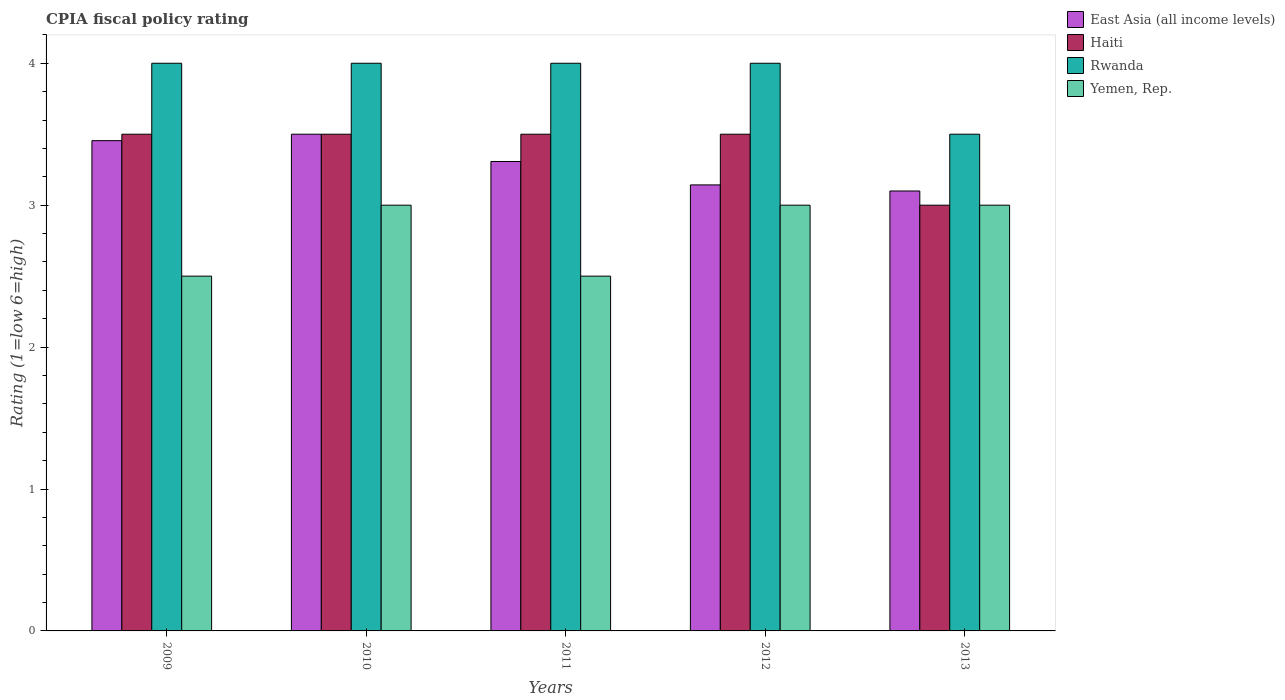How many different coloured bars are there?
Your answer should be compact. 4. Are the number of bars per tick equal to the number of legend labels?
Make the answer very short. Yes. How many bars are there on the 3rd tick from the left?
Make the answer very short. 4. How many bars are there on the 3rd tick from the right?
Your answer should be compact. 4. What is the label of the 1st group of bars from the left?
Make the answer very short. 2009. What is the CPIA rating in Rwanda in 2010?
Give a very brief answer. 4. Across all years, what is the maximum CPIA rating in East Asia (all income levels)?
Provide a succinct answer. 3.5. What is the total CPIA rating in East Asia (all income levels) in the graph?
Your response must be concise. 16.51. What is the difference between the CPIA rating in East Asia (all income levels) in 2009 and that in 2013?
Provide a succinct answer. 0.35. What is the difference between the CPIA rating in East Asia (all income levels) in 2012 and the CPIA rating in Rwanda in 2013?
Provide a succinct answer. -0.36. What is the average CPIA rating in Rwanda per year?
Your response must be concise. 3.9. In the year 2010, what is the difference between the CPIA rating in Yemen, Rep. and CPIA rating in East Asia (all income levels)?
Provide a short and direct response. -0.5. Is the CPIA rating in Rwanda in 2010 less than that in 2012?
Provide a succinct answer. No. What is the difference between the highest and the second highest CPIA rating in Yemen, Rep.?
Provide a succinct answer. 0. What is the difference between the highest and the lowest CPIA rating in East Asia (all income levels)?
Your response must be concise. 0.4. In how many years, is the CPIA rating in Yemen, Rep. greater than the average CPIA rating in Yemen, Rep. taken over all years?
Ensure brevity in your answer.  3. What does the 1st bar from the left in 2011 represents?
Keep it short and to the point. East Asia (all income levels). What does the 4th bar from the right in 2009 represents?
Give a very brief answer. East Asia (all income levels). Are all the bars in the graph horizontal?
Provide a short and direct response. No. Does the graph contain any zero values?
Provide a succinct answer. No. Does the graph contain grids?
Provide a succinct answer. No. Where does the legend appear in the graph?
Your answer should be very brief. Top right. How are the legend labels stacked?
Offer a very short reply. Vertical. What is the title of the graph?
Provide a succinct answer. CPIA fiscal policy rating. What is the label or title of the Y-axis?
Provide a short and direct response. Rating (1=low 6=high). What is the Rating (1=low 6=high) in East Asia (all income levels) in 2009?
Your answer should be very brief. 3.45. What is the Rating (1=low 6=high) of Yemen, Rep. in 2009?
Offer a terse response. 2.5. What is the Rating (1=low 6=high) of Rwanda in 2010?
Offer a terse response. 4. What is the Rating (1=low 6=high) in Yemen, Rep. in 2010?
Give a very brief answer. 3. What is the Rating (1=low 6=high) of East Asia (all income levels) in 2011?
Your answer should be very brief. 3.31. What is the Rating (1=low 6=high) in Haiti in 2011?
Ensure brevity in your answer.  3.5. What is the Rating (1=low 6=high) of Rwanda in 2011?
Offer a very short reply. 4. What is the Rating (1=low 6=high) in East Asia (all income levels) in 2012?
Give a very brief answer. 3.14. What is the Rating (1=low 6=high) of Haiti in 2013?
Give a very brief answer. 3. What is the Rating (1=low 6=high) of Rwanda in 2013?
Give a very brief answer. 3.5. What is the Rating (1=low 6=high) in Yemen, Rep. in 2013?
Make the answer very short. 3. Across all years, what is the maximum Rating (1=low 6=high) in East Asia (all income levels)?
Make the answer very short. 3.5. Across all years, what is the maximum Rating (1=low 6=high) of Rwanda?
Offer a very short reply. 4. Across all years, what is the maximum Rating (1=low 6=high) in Yemen, Rep.?
Your response must be concise. 3. Across all years, what is the minimum Rating (1=low 6=high) of East Asia (all income levels)?
Offer a very short reply. 3.1. What is the total Rating (1=low 6=high) in East Asia (all income levels) in the graph?
Ensure brevity in your answer.  16.51. What is the total Rating (1=low 6=high) in Haiti in the graph?
Ensure brevity in your answer.  17. What is the total Rating (1=low 6=high) in Yemen, Rep. in the graph?
Make the answer very short. 14. What is the difference between the Rating (1=low 6=high) in East Asia (all income levels) in 2009 and that in 2010?
Make the answer very short. -0.05. What is the difference between the Rating (1=low 6=high) of East Asia (all income levels) in 2009 and that in 2011?
Your answer should be very brief. 0.15. What is the difference between the Rating (1=low 6=high) of Rwanda in 2009 and that in 2011?
Your answer should be very brief. 0. What is the difference between the Rating (1=low 6=high) of East Asia (all income levels) in 2009 and that in 2012?
Your answer should be very brief. 0.31. What is the difference between the Rating (1=low 6=high) of Yemen, Rep. in 2009 and that in 2012?
Your answer should be very brief. -0.5. What is the difference between the Rating (1=low 6=high) of East Asia (all income levels) in 2009 and that in 2013?
Make the answer very short. 0.35. What is the difference between the Rating (1=low 6=high) of Rwanda in 2009 and that in 2013?
Your answer should be compact. 0.5. What is the difference between the Rating (1=low 6=high) of East Asia (all income levels) in 2010 and that in 2011?
Ensure brevity in your answer.  0.19. What is the difference between the Rating (1=low 6=high) of Haiti in 2010 and that in 2011?
Your answer should be compact. 0. What is the difference between the Rating (1=low 6=high) of Rwanda in 2010 and that in 2011?
Provide a short and direct response. 0. What is the difference between the Rating (1=low 6=high) of Yemen, Rep. in 2010 and that in 2011?
Your answer should be compact. 0.5. What is the difference between the Rating (1=low 6=high) of East Asia (all income levels) in 2010 and that in 2012?
Provide a succinct answer. 0.36. What is the difference between the Rating (1=low 6=high) in Haiti in 2010 and that in 2012?
Offer a very short reply. 0. What is the difference between the Rating (1=low 6=high) in Yemen, Rep. in 2010 and that in 2012?
Make the answer very short. 0. What is the difference between the Rating (1=low 6=high) of East Asia (all income levels) in 2010 and that in 2013?
Provide a short and direct response. 0.4. What is the difference between the Rating (1=low 6=high) of Haiti in 2010 and that in 2013?
Offer a terse response. 0.5. What is the difference between the Rating (1=low 6=high) of Rwanda in 2010 and that in 2013?
Your response must be concise. 0.5. What is the difference between the Rating (1=low 6=high) of East Asia (all income levels) in 2011 and that in 2012?
Offer a very short reply. 0.16. What is the difference between the Rating (1=low 6=high) of Haiti in 2011 and that in 2012?
Offer a very short reply. 0. What is the difference between the Rating (1=low 6=high) of East Asia (all income levels) in 2011 and that in 2013?
Offer a very short reply. 0.21. What is the difference between the Rating (1=low 6=high) of East Asia (all income levels) in 2012 and that in 2013?
Your answer should be very brief. 0.04. What is the difference between the Rating (1=low 6=high) in Yemen, Rep. in 2012 and that in 2013?
Make the answer very short. 0. What is the difference between the Rating (1=low 6=high) in East Asia (all income levels) in 2009 and the Rating (1=low 6=high) in Haiti in 2010?
Your answer should be compact. -0.05. What is the difference between the Rating (1=low 6=high) of East Asia (all income levels) in 2009 and the Rating (1=low 6=high) of Rwanda in 2010?
Ensure brevity in your answer.  -0.55. What is the difference between the Rating (1=low 6=high) in East Asia (all income levels) in 2009 and the Rating (1=low 6=high) in Yemen, Rep. in 2010?
Offer a terse response. 0.45. What is the difference between the Rating (1=low 6=high) in East Asia (all income levels) in 2009 and the Rating (1=low 6=high) in Haiti in 2011?
Your answer should be compact. -0.05. What is the difference between the Rating (1=low 6=high) in East Asia (all income levels) in 2009 and the Rating (1=low 6=high) in Rwanda in 2011?
Ensure brevity in your answer.  -0.55. What is the difference between the Rating (1=low 6=high) in East Asia (all income levels) in 2009 and the Rating (1=low 6=high) in Yemen, Rep. in 2011?
Your answer should be very brief. 0.95. What is the difference between the Rating (1=low 6=high) of Haiti in 2009 and the Rating (1=low 6=high) of Rwanda in 2011?
Make the answer very short. -0.5. What is the difference between the Rating (1=low 6=high) of Haiti in 2009 and the Rating (1=low 6=high) of Yemen, Rep. in 2011?
Keep it short and to the point. 1. What is the difference between the Rating (1=low 6=high) of East Asia (all income levels) in 2009 and the Rating (1=low 6=high) of Haiti in 2012?
Offer a terse response. -0.05. What is the difference between the Rating (1=low 6=high) of East Asia (all income levels) in 2009 and the Rating (1=low 6=high) of Rwanda in 2012?
Offer a terse response. -0.55. What is the difference between the Rating (1=low 6=high) in East Asia (all income levels) in 2009 and the Rating (1=low 6=high) in Yemen, Rep. in 2012?
Offer a very short reply. 0.45. What is the difference between the Rating (1=low 6=high) of Haiti in 2009 and the Rating (1=low 6=high) of Rwanda in 2012?
Make the answer very short. -0.5. What is the difference between the Rating (1=low 6=high) in Haiti in 2009 and the Rating (1=low 6=high) in Yemen, Rep. in 2012?
Keep it short and to the point. 0.5. What is the difference between the Rating (1=low 6=high) of Rwanda in 2009 and the Rating (1=low 6=high) of Yemen, Rep. in 2012?
Provide a succinct answer. 1. What is the difference between the Rating (1=low 6=high) in East Asia (all income levels) in 2009 and the Rating (1=low 6=high) in Haiti in 2013?
Keep it short and to the point. 0.45. What is the difference between the Rating (1=low 6=high) in East Asia (all income levels) in 2009 and the Rating (1=low 6=high) in Rwanda in 2013?
Your response must be concise. -0.05. What is the difference between the Rating (1=low 6=high) of East Asia (all income levels) in 2009 and the Rating (1=low 6=high) of Yemen, Rep. in 2013?
Make the answer very short. 0.45. What is the difference between the Rating (1=low 6=high) of Haiti in 2009 and the Rating (1=low 6=high) of Rwanda in 2013?
Give a very brief answer. 0. What is the difference between the Rating (1=low 6=high) in Haiti in 2010 and the Rating (1=low 6=high) in Rwanda in 2011?
Your answer should be very brief. -0.5. What is the difference between the Rating (1=low 6=high) in East Asia (all income levels) in 2010 and the Rating (1=low 6=high) in Yemen, Rep. in 2012?
Offer a terse response. 0.5. What is the difference between the Rating (1=low 6=high) in East Asia (all income levels) in 2010 and the Rating (1=low 6=high) in Haiti in 2013?
Ensure brevity in your answer.  0.5. What is the difference between the Rating (1=low 6=high) of East Asia (all income levels) in 2010 and the Rating (1=low 6=high) of Yemen, Rep. in 2013?
Give a very brief answer. 0.5. What is the difference between the Rating (1=low 6=high) of East Asia (all income levels) in 2011 and the Rating (1=low 6=high) of Haiti in 2012?
Your response must be concise. -0.19. What is the difference between the Rating (1=low 6=high) of East Asia (all income levels) in 2011 and the Rating (1=low 6=high) of Rwanda in 2012?
Your answer should be compact. -0.69. What is the difference between the Rating (1=low 6=high) in East Asia (all income levels) in 2011 and the Rating (1=low 6=high) in Yemen, Rep. in 2012?
Keep it short and to the point. 0.31. What is the difference between the Rating (1=low 6=high) of East Asia (all income levels) in 2011 and the Rating (1=low 6=high) of Haiti in 2013?
Make the answer very short. 0.31. What is the difference between the Rating (1=low 6=high) of East Asia (all income levels) in 2011 and the Rating (1=low 6=high) of Rwanda in 2013?
Your response must be concise. -0.19. What is the difference between the Rating (1=low 6=high) in East Asia (all income levels) in 2011 and the Rating (1=low 6=high) in Yemen, Rep. in 2013?
Your answer should be compact. 0.31. What is the difference between the Rating (1=low 6=high) in Haiti in 2011 and the Rating (1=low 6=high) in Yemen, Rep. in 2013?
Provide a short and direct response. 0.5. What is the difference between the Rating (1=low 6=high) of Rwanda in 2011 and the Rating (1=low 6=high) of Yemen, Rep. in 2013?
Offer a very short reply. 1. What is the difference between the Rating (1=low 6=high) in East Asia (all income levels) in 2012 and the Rating (1=low 6=high) in Haiti in 2013?
Keep it short and to the point. 0.14. What is the difference between the Rating (1=low 6=high) in East Asia (all income levels) in 2012 and the Rating (1=low 6=high) in Rwanda in 2013?
Your answer should be very brief. -0.36. What is the difference between the Rating (1=low 6=high) of East Asia (all income levels) in 2012 and the Rating (1=low 6=high) of Yemen, Rep. in 2013?
Give a very brief answer. 0.14. What is the difference between the Rating (1=low 6=high) in Haiti in 2012 and the Rating (1=low 6=high) in Yemen, Rep. in 2013?
Give a very brief answer. 0.5. What is the average Rating (1=low 6=high) of East Asia (all income levels) per year?
Your answer should be compact. 3.3. What is the average Rating (1=low 6=high) in Rwanda per year?
Ensure brevity in your answer.  3.9. What is the average Rating (1=low 6=high) in Yemen, Rep. per year?
Provide a succinct answer. 2.8. In the year 2009, what is the difference between the Rating (1=low 6=high) in East Asia (all income levels) and Rating (1=low 6=high) in Haiti?
Give a very brief answer. -0.05. In the year 2009, what is the difference between the Rating (1=low 6=high) in East Asia (all income levels) and Rating (1=low 6=high) in Rwanda?
Provide a short and direct response. -0.55. In the year 2009, what is the difference between the Rating (1=low 6=high) in East Asia (all income levels) and Rating (1=low 6=high) in Yemen, Rep.?
Your answer should be very brief. 0.95. In the year 2009, what is the difference between the Rating (1=low 6=high) in Haiti and Rating (1=low 6=high) in Rwanda?
Provide a succinct answer. -0.5. In the year 2009, what is the difference between the Rating (1=low 6=high) of Rwanda and Rating (1=low 6=high) of Yemen, Rep.?
Keep it short and to the point. 1.5. In the year 2010, what is the difference between the Rating (1=low 6=high) in East Asia (all income levels) and Rating (1=low 6=high) in Haiti?
Offer a very short reply. 0. In the year 2010, what is the difference between the Rating (1=low 6=high) in East Asia (all income levels) and Rating (1=low 6=high) in Rwanda?
Ensure brevity in your answer.  -0.5. In the year 2010, what is the difference between the Rating (1=low 6=high) of Haiti and Rating (1=low 6=high) of Rwanda?
Keep it short and to the point. -0.5. In the year 2010, what is the difference between the Rating (1=low 6=high) in Haiti and Rating (1=low 6=high) in Yemen, Rep.?
Keep it short and to the point. 0.5. In the year 2010, what is the difference between the Rating (1=low 6=high) of Rwanda and Rating (1=low 6=high) of Yemen, Rep.?
Keep it short and to the point. 1. In the year 2011, what is the difference between the Rating (1=low 6=high) in East Asia (all income levels) and Rating (1=low 6=high) in Haiti?
Offer a very short reply. -0.19. In the year 2011, what is the difference between the Rating (1=low 6=high) in East Asia (all income levels) and Rating (1=low 6=high) in Rwanda?
Give a very brief answer. -0.69. In the year 2011, what is the difference between the Rating (1=low 6=high) in East Asia (all income levels) and Rating (1=low 6=high) in Yemen, Rep.?
Ensure brevity in your answer.  0.81. In the year 2011, what is the difference between the Rating (1=low 6=high) of Rwanda and Rating (1=low 6=high) of Yemen, Rep.?
Provide a short and direct response. 1.5. In the year 2012, what is the difference between the Rating (1=low 6=high) of East Asia (all income levels) and Rating (1=low 6=high) of Haiti?
Offer a terse response. -0.36. In the year 2012, what is the difference between the Rating (1=low 6=high) of East Asia (all income levels) and Rating (1=low 6=high) of Rwanda?
Provide a succinct answer. -0.86. In the year 2012, what is the difference between the Rating (1=low 6=high) of East Asia (all income levels) and Rating (1=low 6=high) of Yemen, Rep.?
Offer a terse response. 0.14. In the year 2012, what is the difference between the Rating (1=low 6=high) in Haiti and Rating (1=low 6=high) in Rwanda?
Give a very brief answer. -0.5. In the year 2012, what is the difference between the Rating (1=low 6=high) in Rwanda and Rating (1=low 6=high) in Yemen, Rep.?
Give a very brief answer. 1. In the year 2013, what is the difference between the Rating (1=low 6=high) in East Asia (all income levels) and Rating (1=low 6=high) in Rwanda?
Ensure brevity in your answer.  -0.4. In the year 2013, what is the difference between the Rating (1=low 6=high) of Haiti and Rating (1=low 6=high) of Yemen, Rep.?
Make the answer very short. 0. In the year 2013, what is the difference between the Rating (1=low 6=high) in Rwanda and Rating (1=low 6=high) in Yemen, Rep.?
Offer a terse response. 0.5. What is the ratio of the Rating (1=low 6=high) of East Asia (all income levels) in 2009 to that in 2010?
Keep it short and to the point. 0.99. What is the ratio of the Rating (1=low 6=high) of Rwanda in 2009 to that in 2010?
Provide a succinct answer. 1. What is the ratio of the Rating (1=low 6=high) in Yemen, Rep. in 2009 to that in 2010?
Give a very brief answer. 0.83. What is the ratio of the Rating (1=low 6=high) of East Asia (all income levels) in 2009 to that in 2011?
Make the answer very short. 1.04. What is the ratio of the Rating (1=low 6=high) of Haiti in 2009 to that in 2011?
Your answer should be very brief. 1. What is the ratio of the Rating (1=low 6=high) in Yemen, Rep. in 2009 to that in 2011?
Your response must be concise. 1. What is the ratio of the Rating (1=low 6=high) in East Asia (all income levels) in 2009 to that in 2012?
Make the answer very short. 1.1. What is the ratio of the Rating (1=low 6=high) of Haiti in 2009 to that in 2012?
Give a very brief answer. 1. What is the ratio of the Rating (1=low 6=high) in Rwanda in 2009 to that in 2012?
Your answer should be very brief. 1. What is the ratio of the Rating (1=low 6=high) in East Asia (all income levels) in 2009 to that in 2013?
Your answer should be compact. 1.11. What is the ratio of the Rating (1=low 6=high) of Haiti in 2009 to that in 2013?
Keep it short and to the point. 1.17. What is the ratio of the Rating (1=low 6=high) in Rwanda in 2009 to that in 2013?
Keep it short and to the point. 1.14. What is the ratio of the Rating (1=low 6=high) of Yemen, Rep. in 2009 to that in 2013?
Make the answer very short. 0.83. What is the ratio of the Rating (1=low 6=high) in East Asia (all income levels) in 2010 to that in 2011?
Your response must be concise. 1.06. What is the ratio of the Rating (1=low 6=high) of Haiti in 2010 to that in 2011?
Ensure brevity in your answer.  1. What is the ratio of the Rating (1=low 6=high) in Rwanda in 2010 to that in 2011?
Make the answer very short. 1. What is the ratio of the Rating (1=low 6=high) of Yemen, Rep. in 2010 to that in 2011?
Make the answer very short. 1.2. What is the ratio of the Rating (1=low 6=high) of East Asia (all income levels) in 2010 to that in 2012?
Provide a succinct answer. 1.11. What is the ratio of the Rating (1=low 6=high) in Haiti in 2010 to that in 2012?
Provide a succinct answer. 1. What is the ratio of the Rating (1=low 6=high) of Rwanda in 2010 to that in 2012?
Ensure brevity in your answer.  1. What is the ratio of the Rating (1=low 6=high) of East Asia (all income levels) in 2010 to that in 2013?
Your answer should be compact. 1.13. What is the ratio of the Rating (1=low 6=high) of Haiti in 2010 to that in 2013?
Provide a succinct answer. 1.17. What is the ratio of the Rating (1=low 6=high) in Yemen, Rep. in 2010 to that in 2013?
Your response must be concise. 1. What is the ratio of the Rating (1=low 6=high) in East Asia (all income levels) in 2011 to that in 2012?
Provide a succinct answer. 1.05. What is the ratio of the Rating (1=low 6=high) of East Asia (all income levels) in 2011 to that in 2013?
Provide a short and direct response. 1.07. What is the ratio of the Rating (1=low 6=high) in Haiti in 2011 to that in 2013?
Your answer should be very brief. 1.17. What is the ratio of the Rating (1=low 6=high) of Yemen, Rep. in 2011 to that in 2013?
Your answer should be compact. 0.83. What is the ratio of the Rating (1=low 6=high) of East Asia (all income levels) in 2012 to that in 2013?
Ensure brevity in your answer.  1.01. What is the difference between the highest and the second highest Rating (1=low 6=high) of East Asia (all income levels)?
Provide a short and direct response. 0.05. What is the difference between the highest and the second highest Rating (1=low 6=high) in Rwanda?
Ensure brevity in your answer.  0. What is the difference between the highest and the lowest Rating (1=low 6=high) of East Asia (all income levels)?
Your answer should be very brief. 0.4. What is the difference between the highest and the lowest Rating (1=low 6=high) of Haiti?
Make the answer very short. 0.5. 